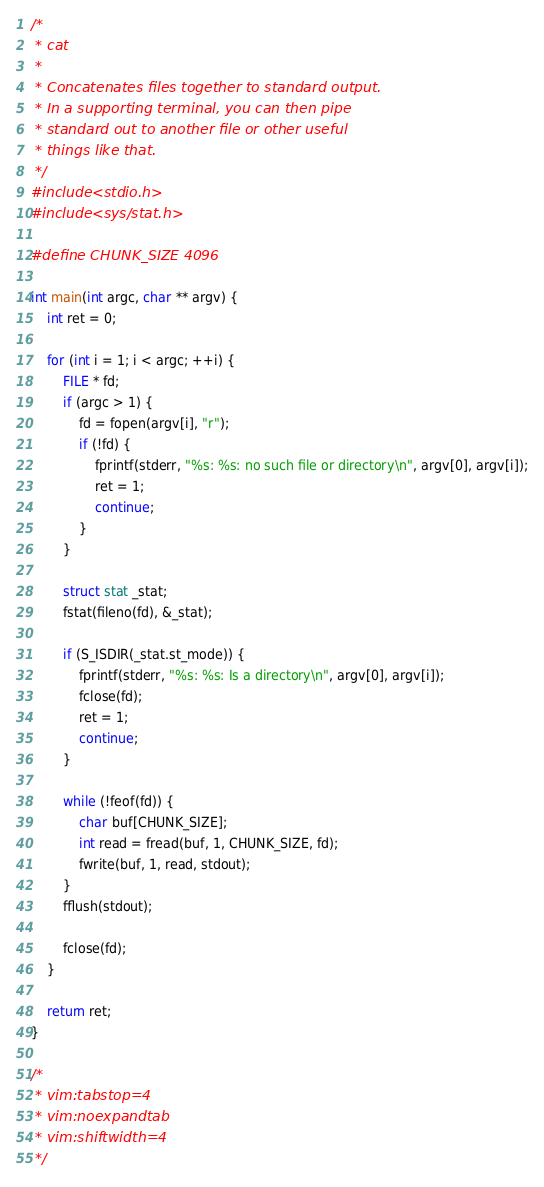<code> <loc_0><loc_0><loc_500><loc_500><_C_>/*
 * cat
 *
 * Concatenates files together to standard output.
 * In a supporting terminal, you can then pipe
 * standard out to another file or other useful
 * things like that.
 */
#include <stdio.h>
#include <sys/stat.h>

#define CHUNK_SIZE 4096

int main(int argc, char ** argv) {
	int ret = 0;

	for (int i = 1; i < argc; ++i) {
		FILE * fd;
		if (argc > 1) {
			fd = fopen(argv[i], "r");
			if (!fd) {
				fprintf(stderr, "%s: %s: no such file or directory\n", argv[0], argv[i]);
				ret = 1;
				continue;
			}
		}

		struct stat _stat;
		fstat(fileno(fd), &_stat);

		if (S_ISDIR(_stat.st_mode)) {
			fprintf(stderr, "%s: %s: Is a directory\n", argv[0], argv[i]);
			fclose(fd);
			ret = 1;
			continue;
		}

		while (!feof(fd)) {
			char buf[CHUNK_SIZE];
			int read = fread(buf, 1, CHUNK_SIZE, fd);
			fwrite(buf, 1, read, stdout);
		}
		fflush(stdout);

		fclose(fd);
	}

	return ret;
}

/*
 * vim:tabstop=4
 * vim:noexpandtab
 * vim:shiftwidth=4
 */
</code> 